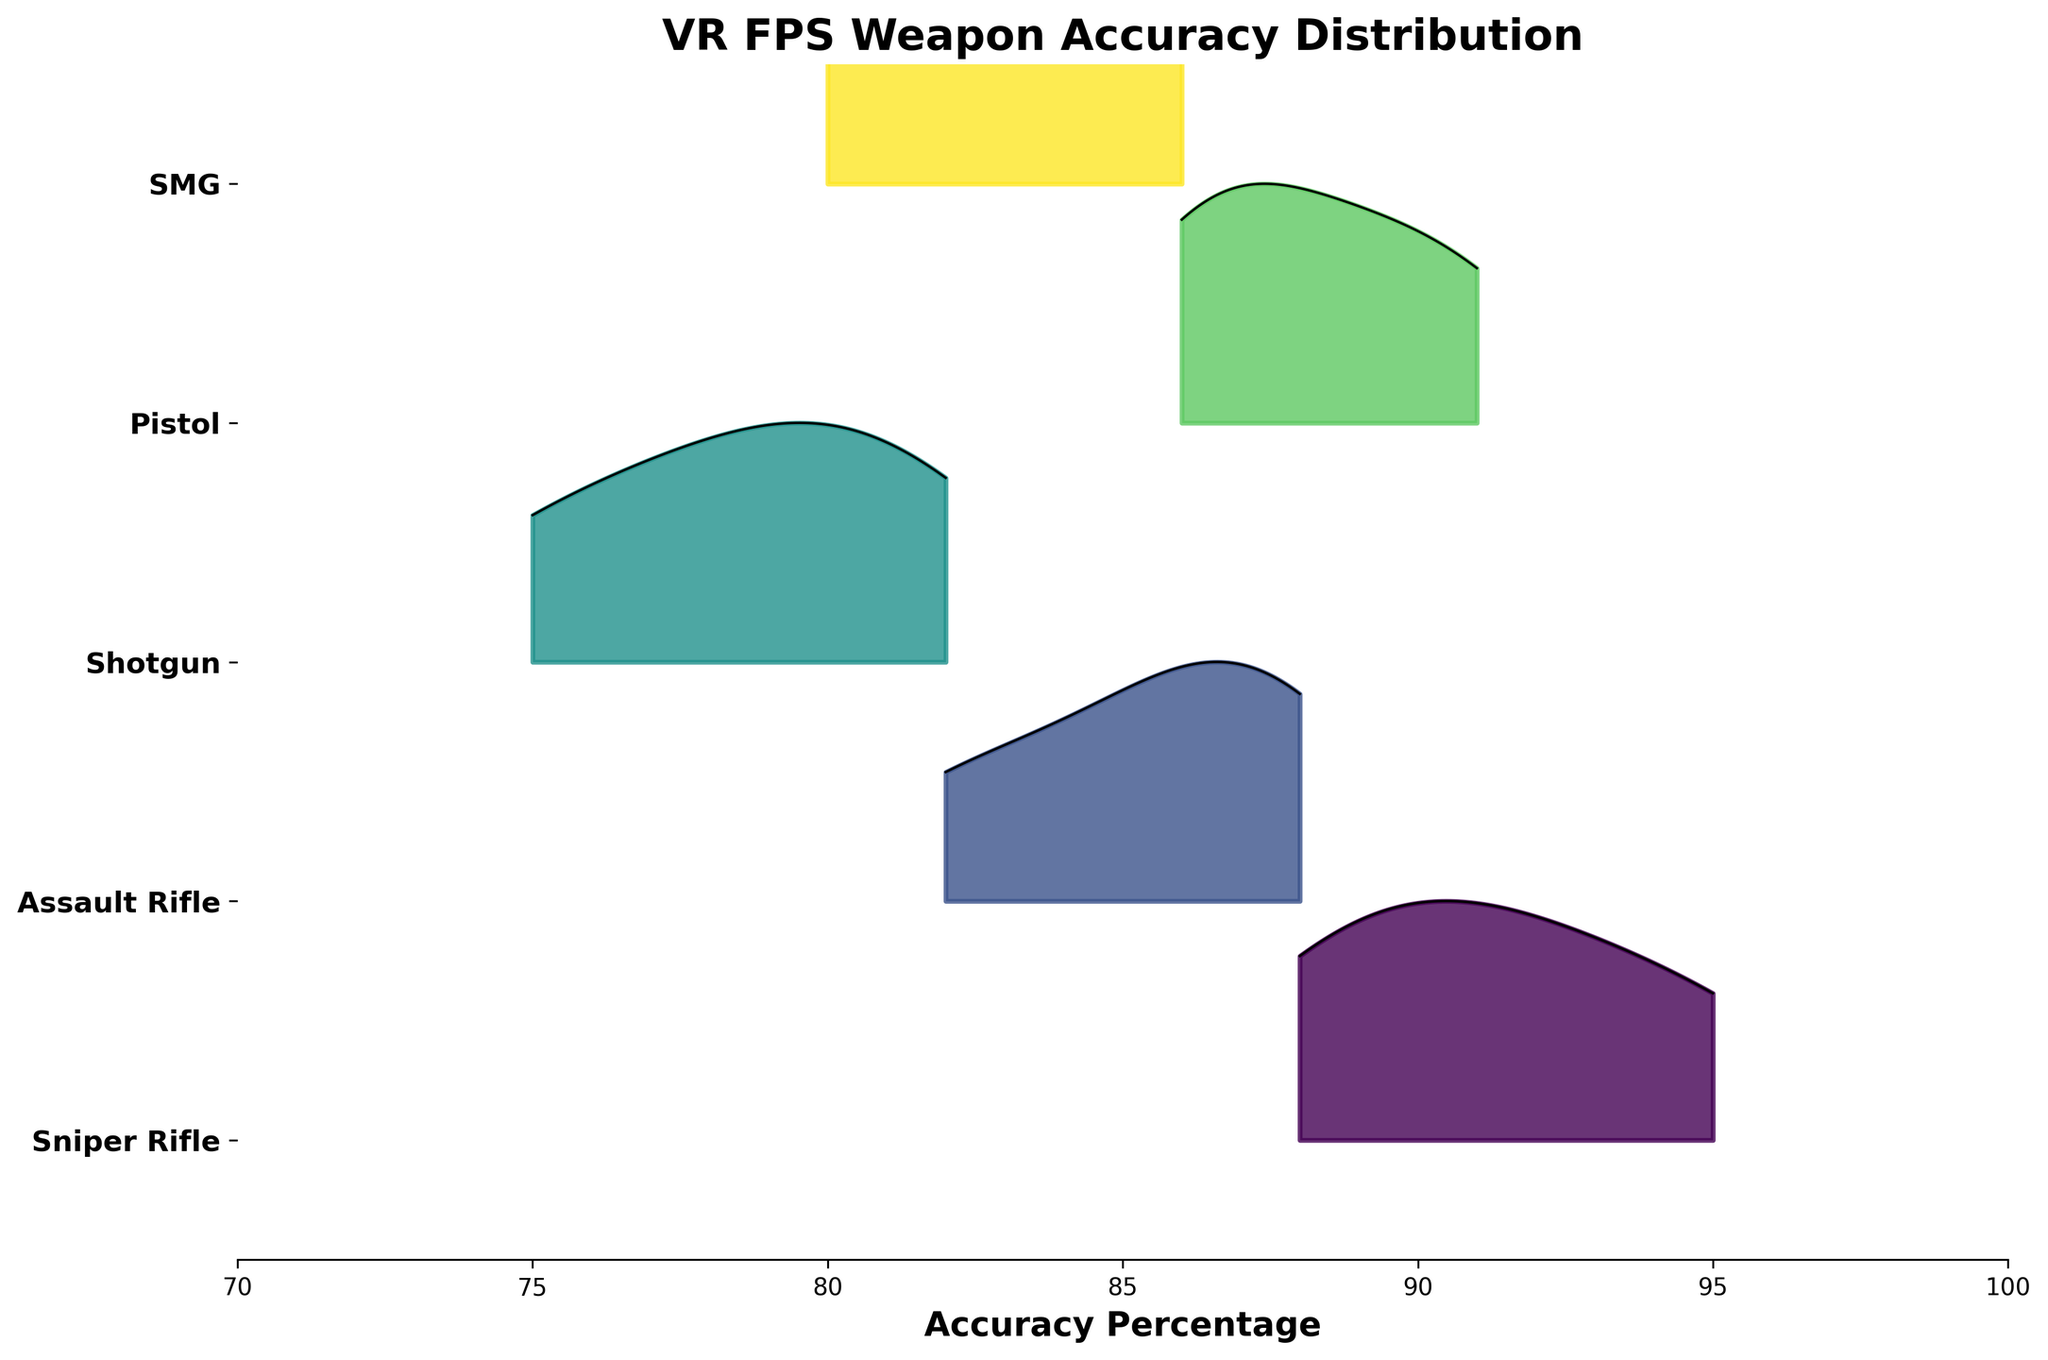what's the title of the figure? The title is typically placed at the top of the figure. In this case, it is written in a bold and larger font to highlight it as the title.
Answer: VR FPS Weapon Accuracy Distribution how many weapon types are shown in the plot? The figure shows different colored ridgelines, each corresponding to a particular weapon type. By counting the distinct lines from top to bottom, we can identify the number of weapon types.
Answer: 5 which weapon type has the widest distribution in accuracy percentage? To determine the widest distribution, observe which ridgeline covers a broader range on the x-axis. The SMG ridgeline appears to spread from around 80 to 86 accuracy percentage, indicating a wide distribution.
Answer: SMG which weapon type has the highest peak in accuracy percentage? The height of the ridgeline's peak shows the density of the accuracy percentages. The Sniper Rifle's ridgeline has the highest peak, indicating it has the highest concentration of accuracy percentages.
Answer: Sniper Rifle between Sniper Rifle and Shotgun, which has a higher average accuracy percentage? The average can be inferred by looking at the location of the peaks and the spread around them. The Sniper Rifle has higher average accuracy as its peak is around 91-92, while the Shotgun's peak is around 78-80.
Answer: Sniper Rifle what range of accuracy percentage does the Assault Rifle cover? By observing the start and end points of the ridgeline for the Assault Rifle, its range can be determined. The ridgeline spans from around 82 to 88 accuracy percentage.
Answer: 82-88 what is the approximate median accuracy percentage for the Pistol? The median is typically near the peak of the ridgeline since it shows where the most data points accumulate. For the Pistol, the peak is located around 87-89.
Answer: 88 how do the accuracy distributions of the SMG and Pistol compare? Comparing the ridgelines of both SMG and Pistol, the SMG has a broader range with a lower peak, indicating more spread accuracy percentages. The Pistol has a narrower distribution with a higher peak, indicating a higher concentration around a specific accuracy.
Answer: SMG is broader, Pistol is narrower which weapon type shows a higher variability in accuracy percentages, Shotgun or Assault Rifle? Variability can be identified by how spread out the ridgeline is. The Shotgun's ridgeline spans a wider range compared to the more compressed range of the Assault Rifle.
Answer: Shotgun 